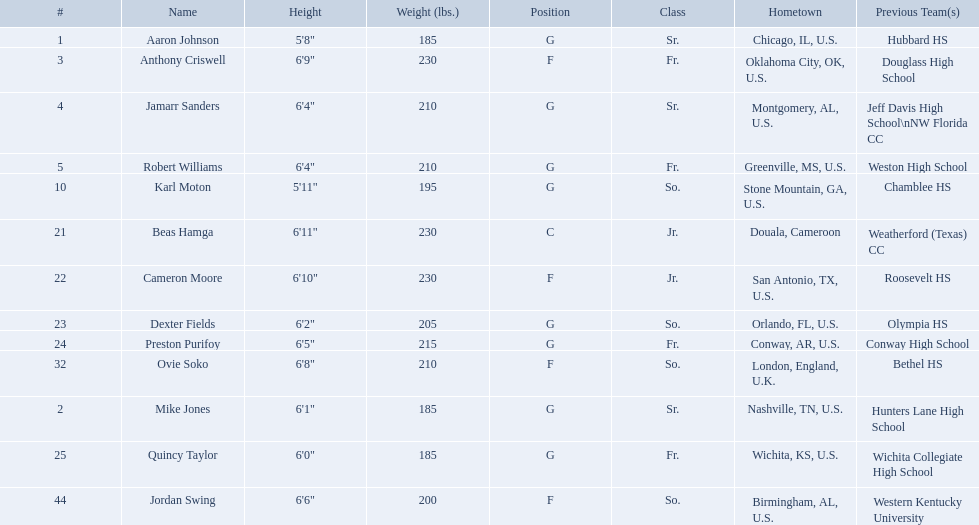Other than soko, who are the players? Aaron Johnson, Anthony Criswell, Jamarr Sanders, Robert Williams, Karl Moton, Beas Hamga, Cameron Moore, Dexter Fields, Preston Purifoy, Mike Jones, Quincy Taylor, Jordan Swing. Of those players, who is a player that is not from the us? Beas Hamga. Write the full table. {'header': ['#', 'Name', 'Height', 'Weight (lbs.)', 'Position', 'Class', 'Hometown', 'Previous Team(s)'], 'rows': [['1', 'Aaron Johnson', '5\'8"', '185', 'G', 'Sr.', 'Chicago, IL, U.S.', 'Hubbard HS'], ['3', 'Anthony Criswell', '6\'9"', '230', 'F', 'Fr.', 'Oklahoma City, OK, U.S.', 'Douglass High School'], ['4', 'Jamarr Sanders', '6\'4"', '210', 'G', 'Sr.', 'Montgomery, AL, U.S.', 'Jeff Davis High School\\nNW Florida CC'], ['5', 'Robert Williams', '6\'4"', '210', 'G', 'Fr.', 'Greenville, MS, U.S.', 'Weston High School'], ['10', 'Karl Moton', '5\'11"', '195', 'G', 'So.', 'Stone Mountain, GA, U.S.', 'Chamblee HS'], ['21', 'Beas Hamga', '6\'11"', '230', 'C', 'Jr.', 'Douala, Cameroon', 'Weatherford (Texas) CC'], ['22', 'Cameron Moore', '6\'10"', '230', 'F', 'Jr.', 'San Antonio, TX, U.S.', 'Roosevelt HS'], ['23', 'Dexter Fields', '6\'2"', '205', 'G', 'So.', 'Orlando, FL, U.S.', 'Olympia HS'], ['24', 'Preston Purifoy', '6\'5"', '215', 'G', 'Fr.', 'Conway, AR, U.S.', 'Conway High School'], ['32', 'Ovie Soko', '6\'8"', '210', 'F', 'So.', 'London, England, U.K.', 'Bethel HS'], ['2', 'Mike Jones', '6\'1"', '185', 'G', 'Sr.', 'Nashville, TN, U.S.', 'Hunters Lane High School'], ['25', 'Quincy Taylor', '6\'0"', '185', 'G', 'Fr.', 'Wichita, KS, U.S.', 'Wichita Collegiate High School'], ['44', 'Jordan Swing', '6\'6"', '200', 'F', 'So.', 'Birmingham, AL, U.S.', 'Western Kentucky University']]} Who are all the individuals involved? Aaron Johnson, Anthony Criswell, Jamarr Sanders, Robert Williams, Karl Moton, Beas Hamga, Cameron Moore, Dexter Fields, Preston Purifoy, Ovie Soko, Mike Jones, Quincy Taylor, Jordan Swing. Of these, which are not soko? Aaron Johnson, Anthony Criswell, Jamarr Sanders, Robert Williams, Karl Moton, Beas Hamga, Cameron Moore, Dexter Fields, Preston Purifoy, Mike Jones, Quincy Taylor, Jordan Swing. Where do these individuals hail from? Sr., Fr., Sr., Fr., So., Jr., Jr., So., Fr., Sr., Fr., So. Of these locales, which are not in the u.s.? Jr. Which individual is from this locale? Beas Hamga. Excluding soko, who are the contenders? Aaron Johnson, Anthony Criswell, Jamarr Sanders, Robert Williams, Karl Moton, Beas Hamga, Cameron Moore, Dexter Fields, Preston Purifoy, Mike Jones, Quincy Taylor, Jordan Swing. Of those contenders, who is a person not native to the us? Beas Hamga. Who are all the participants? Aaron Johnson, Anthony Criswell, Jamarr Sanders, Robert Williams, Karl Moton, Beas Hamga, Cameron Moore, Dexter Fields, Preston Purifoy, Ovie Soko, Mike Jones, Quincy Taylor, Jordan Swing. Among them, who is not soko? Aaron Johnson, Anthony Criswell, Jamarr Sanders, Robert Williams, Karl Moton, Beas Hamga, Cameron Moore, Dexter Fields, Preston Purifoy, Mike Jones, Quincy Taylor, Jordan Swing. What are their origins? Sr., Fr., Sr., Fr., So., Jr., Jr., So., Fr., Sr., Fr., So. From these places, which ones are not in the u.s.? Jr. Which participant hails from this place? Beas Hamga. Can you list all the players? Aaron Johnson, Anthony Criswell, Jamarr Sanders, Robert Williams, Karl Moton, Beas Hamga, Cameron Moore, Dexter Fields, Preston Purifoy, Ovie Soko, Mike Jones, Quincy Taylor, Jordan Swing. Who among them is not soko? Aaron Johnson, Anthony Criswell, Jamarr Sanders, Robert Williams, Karl Moton, Beas Hamga, Cameron Moore, Dexter Fields, Preston Purifoy, Mike Jones, Quincy Taylor, Jordan Swing. What are their countries of origin? Sr., Fr., Sr., Fr., So., Jr., Jr., So., Fr., Sr., Fr., So. Out of these countries, which are not located in the united states? Jr. Which player comes from this non-u.s. location? Beas Hamga. Besides soko, who are the other participants? Aaron Johnson, Anthony Criswell, Jamarr Sanders, Robert Williams, Karl Moton, Beas Hamga, Cameron Moore, Dexter Fields, Preston Purifoy, Mike Jones, Quincy Taylor, Jordan Swing. Among them, who is a non-us player? Beas Hamga. Apart from soko, who else is playing? Aaron Johnson, Anthony Criswell, Jamarr Sanders, Robert Williams, Karl Moton, Beas Hamga, Cameron Moore, Dexter Fields, Preston Purifoy, Mike Jones, Quincy Taylor, Jordan Swing. From that group, who is a player originating outside the us? Beas Hamga. 